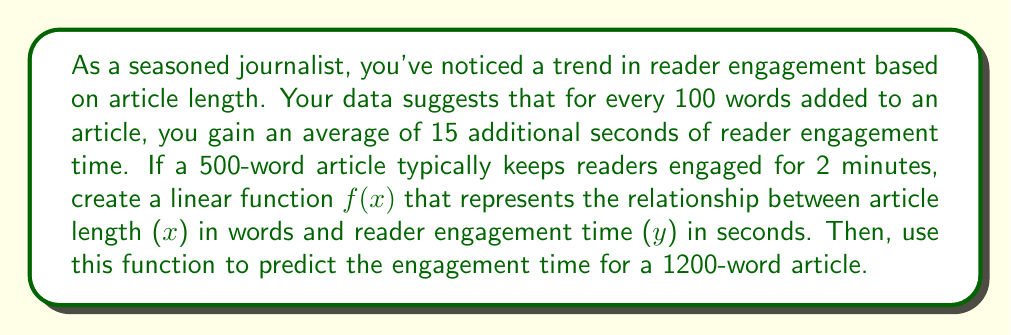Help me with this question. Let's approach this step-by-step:

1) First, we need to identify our known points:
   - A 500-word article engages readers for 2 minutes (120 seconds)
   - For every 100 words, engagement increases by 15 seconds

2) We can represent this as a linear function in the form $f(x) = mx + b$, where:
   - $m$ is the slope (rate of change)
   - $b$ is the y-intercept (engagement time when word count is 0)

3) Calculate the slope $m$:
   $m = \frac{\text{change in y}}{\text{change in x}} = \frac{15 \text{ seconds}}{100 \text{ words}} = 0.15 \text{ seconds/word}$

4) Now we can use the point (500, 120) to find $b$:
   $120 = 0.15(500) + b$
   $120 = 75 + b$
   $b = 45$

5) Our linear function is therefore:
   $f(x) = 0.15x + 45$

6) To predict the engagement time for a 1200-word article, we simply input 1200 for x:
   $f(1200) = 0.15(1200) + 45 = 180 + 45 = 225$

Thus, a 1200-word article is predicted to engage readers for 225 seconds, or 3 minutes and 45 seconds.
Answer: The linear function is $f(x) = 0.15x + 45$, where $x$ is the number of words and $f(x)$ is the engagement time in seconds. For a 1200-word article, the predicted engagement time is 225 seconds (3 minutes and 45 seconds). 